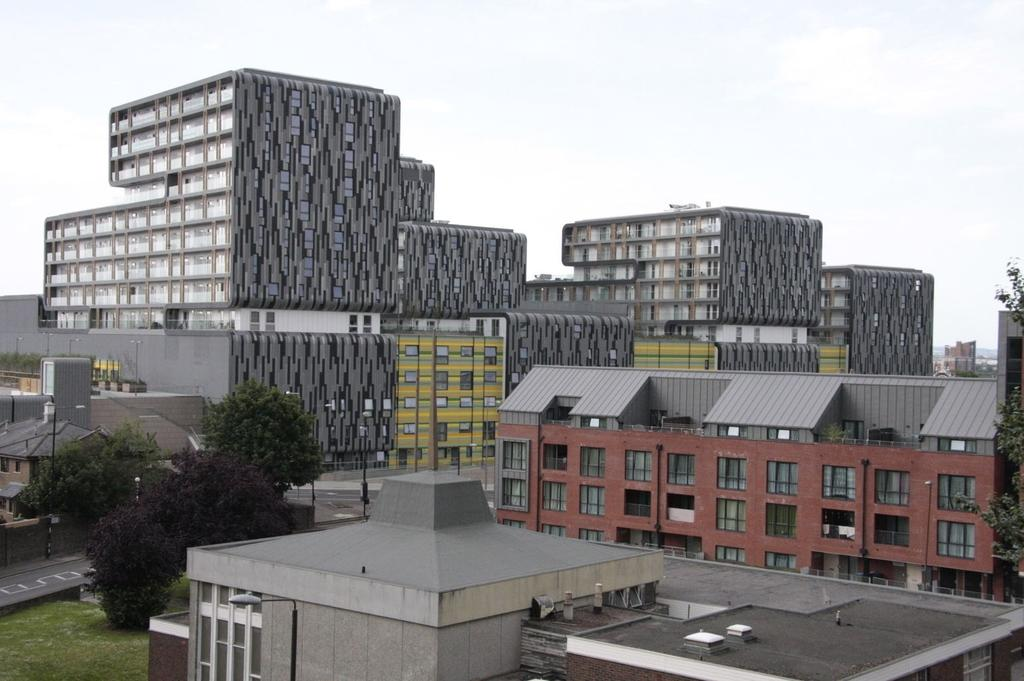What type of structures can be seen in the image? There are buildings in the image. What type of vegetation is present in the image? There are trees in the image. What are the tall, thin objects in the image? There are poles in the image. What type of pathways are visible in the image? There are roads in the image. What type of ground cover is present in the image? There is grass on the ground in the image. What can be seen in the sky in the background of the image? There are clouds in the sky in the background of the image. Where is the chair located in the image? There is no chair present in the image. What type of school can be seen in the image? There is no school present in the image. 